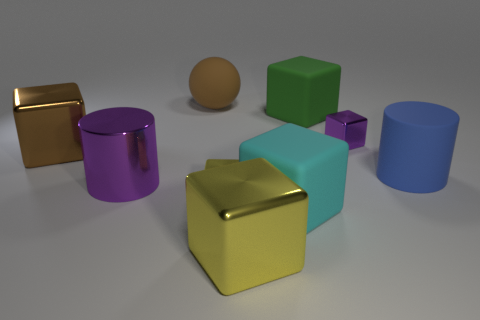What number of other things are the same size as the cyan block?
Make the answer very short. 6. Are there any green rubber blocks of the same size as the blue thing?
Your answer should be compact. Yes. There is a cube left of the ball; does it have the same color as the large sphere?
Give a very brief answer. Yes. What number of things are either big green cubes or large purple rubber objects?
Offer a terse response. 1. Do the metallic block right of the green cube and the metal cylinder have the same size?
Your answer should be compact. No. What is the size of the rubber thing that is in front of the big brown rubber sphere and behind the blue matte cylinder?
Your response must be concise. Large. What number of other things are there of the same shape as the brown rubber thing?
Ensure brevity in your answer.  0. How many other objects are there of the same material as the small yellow object?
Offer a very short reply. 4. What is the size of the other rubber object that is the same shape as the green matte thing?
Your answer should be very brief. Large. Is the large matte cylinder the same color as the large ball?
Offer a very short reply. No. 